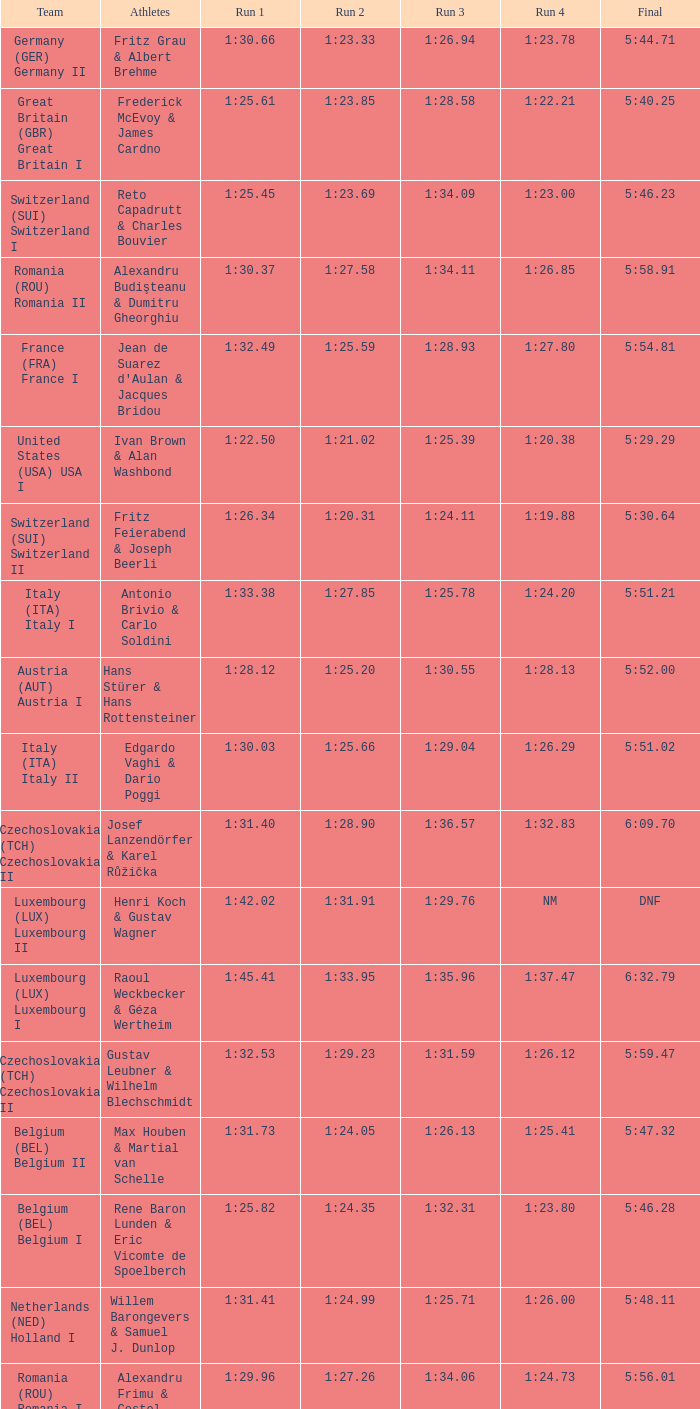Which Final has a Run 2 of 1:27.58? 5:58.91. 